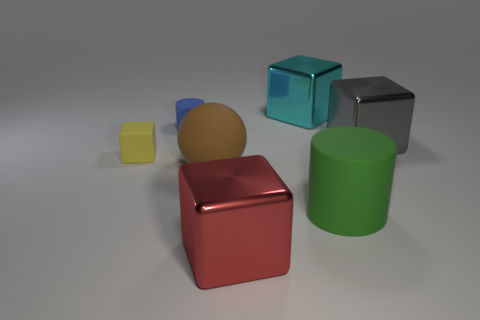Is there any other thing that has the same shape as the big brown thing?
Your answer should be compact. No. Are there any small rubber cubes that are on the left side of the large object in front of the large green thing?
Your answer should be compact. Yes. How many big things are both behind the green matte cylinder and in front of the large cyan shiny block?
Provide a short and direct response. 2. There is a large gray metal object that is in front of the big cyan metal thing; what is its shape?
Make the answer very short. Cube. What number of yellow objects have the same size as the yellow matte cube?
Give a very brief answer. 0. The cube that is to the right of the big matte sphere and in front of the gray block is made of what material?
Provide a succinct answer. Metal. Are there more brown spheres than tiny gray shiny balls?
Offer a very short reply. Yes. There is a big metal object in front of the block that is on the left side of the matte cylinder on the left side of the large red metal cube; what color is it?
Provide a succinct answer. Red. Is the block to the right of the big cyan thing made of the same material as the big red thing?
Make the answer very short. Yes. Are any yellow metallic things visible?
Offer a terse response. No. 